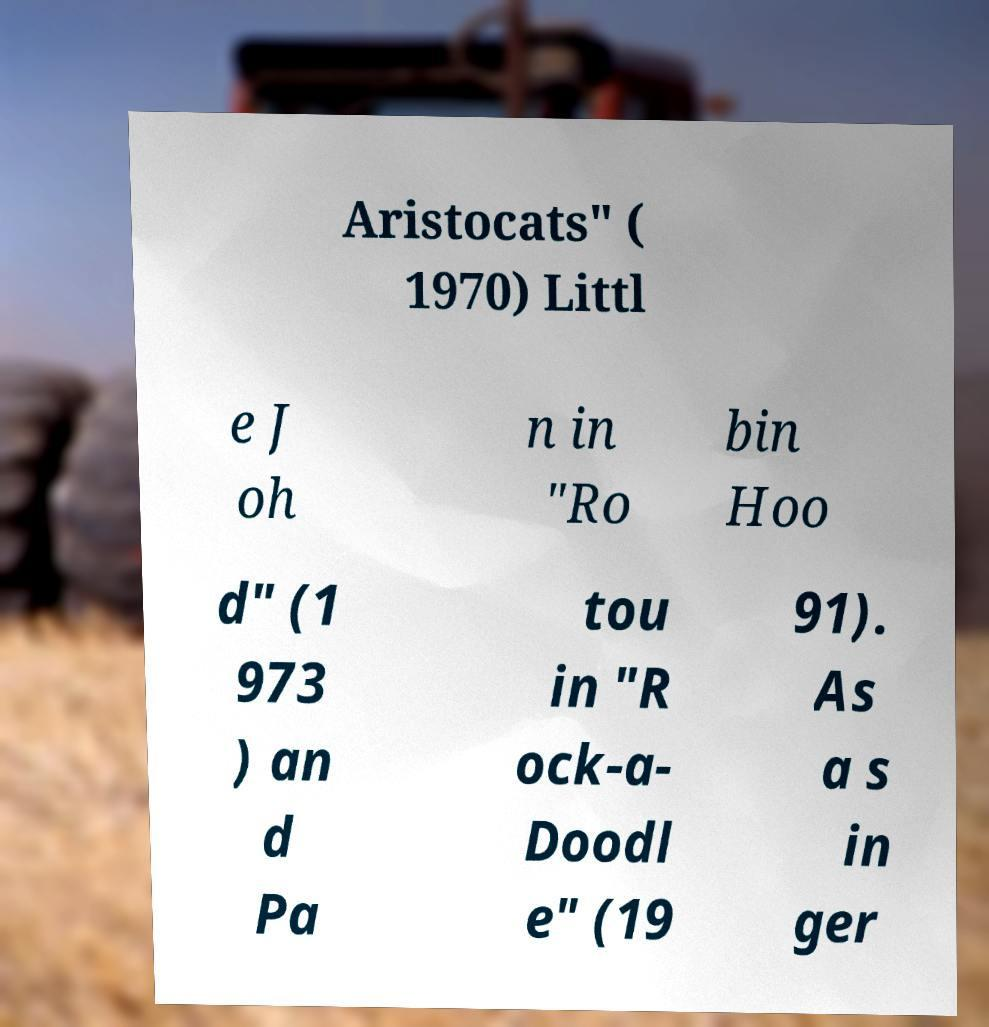Could you assist in decoding the text presented in this image and type it out clearly? Aristocats" ( 1970) Littl e J oh n in "Ro bin Hoo d" (1 973 ) an d Pa tou in "R ock-a- Doodl e" (19 91). As a s in ger 